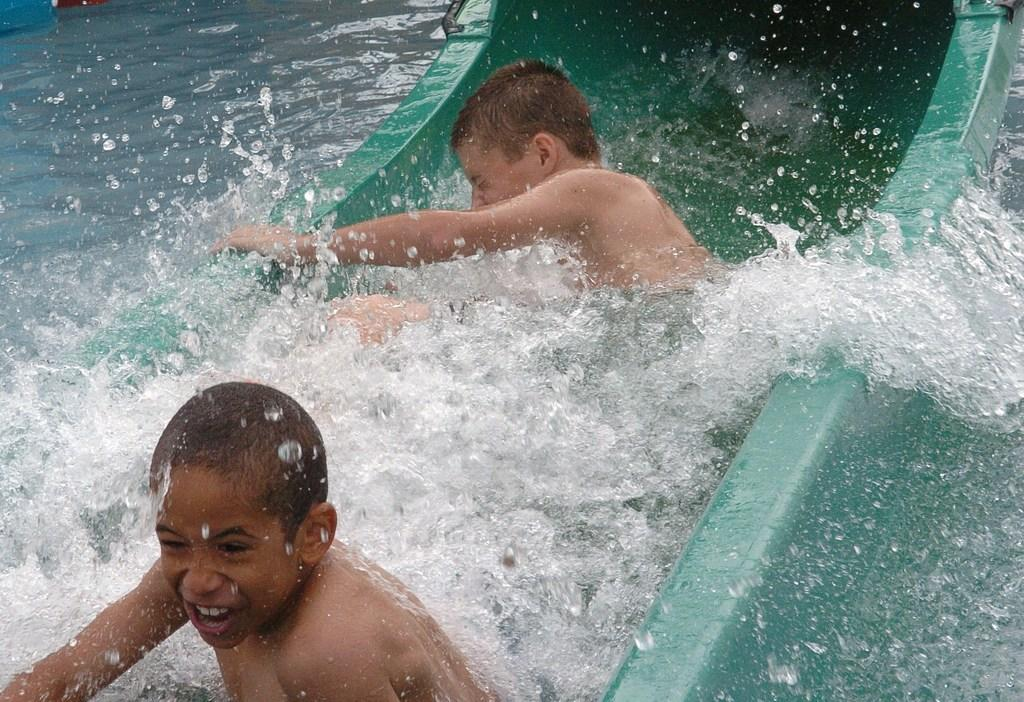How many boys are present in the image? There are two boys in the image. What is the setting in which the boys are located? The boys are in the water. What object are the boys holding in the image? The boys are holding a slide with their hands. What type of drum can be seen being played by one of the boys in the image? There is no drum present in the image; the boys are holding a slide. Can you tell me how many crayons are visible in the image? There are no crayons present in the image. 